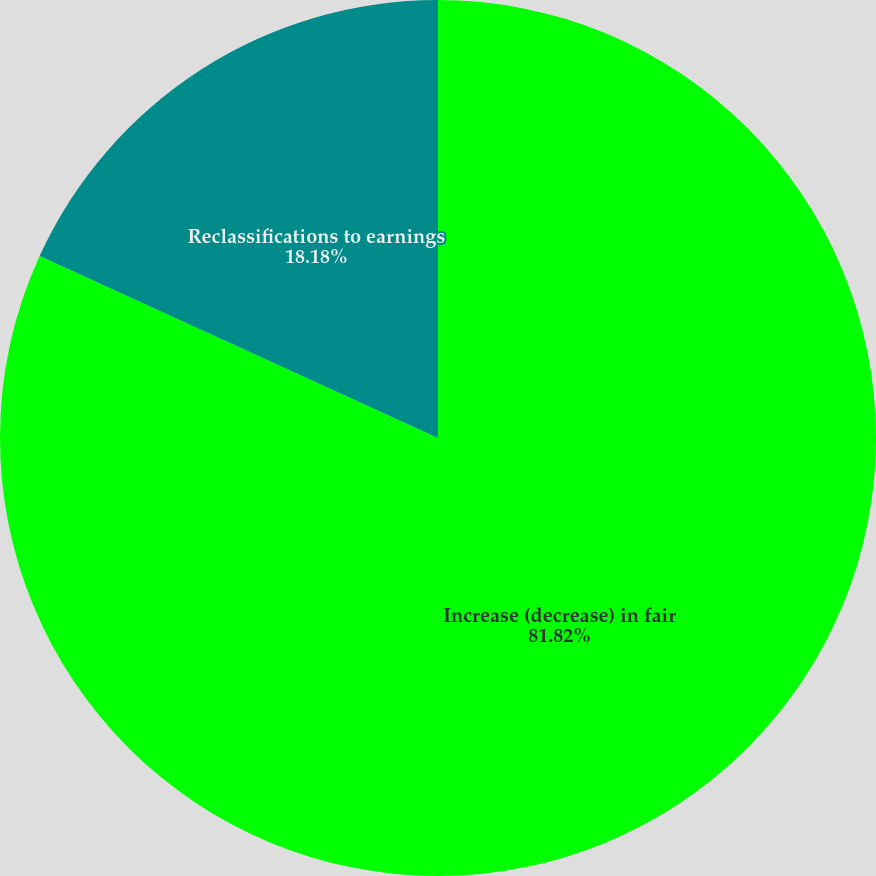Convert chart to OTSL. <chart><loc_0><loc_0><loc_500><loc_500><pie_chart><fcel>Increase (decrease) in fair<fcel>Reclassifications to earnings<nl><fcel>81.82%<fcel>18.18%<nl></chart> 